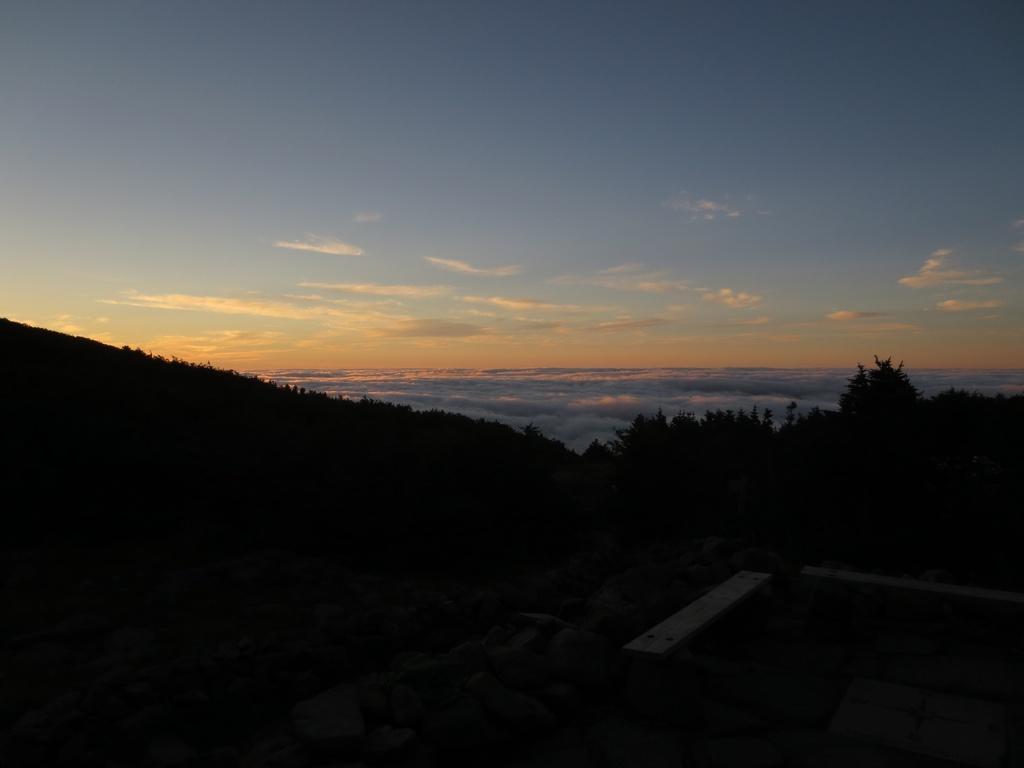Can you describe this image briefly? In this picture we can see a few stones, bench and a few objects on the right side. There are a few trees visible from left to right. Sky is cloudy. We can see a dark view at the bottom of the picture. 